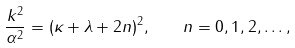Convert formula to latex. <formula><loc_0><loc_0><loc_500><loc_500>\frac { k ^ { 2 } } { \alpha ^ { 2 } } = ( \kappa + \lambda + 2 n ) ^ { 2 } , \quad n = 0 , 1 , 2 , \dots ,</formula> 